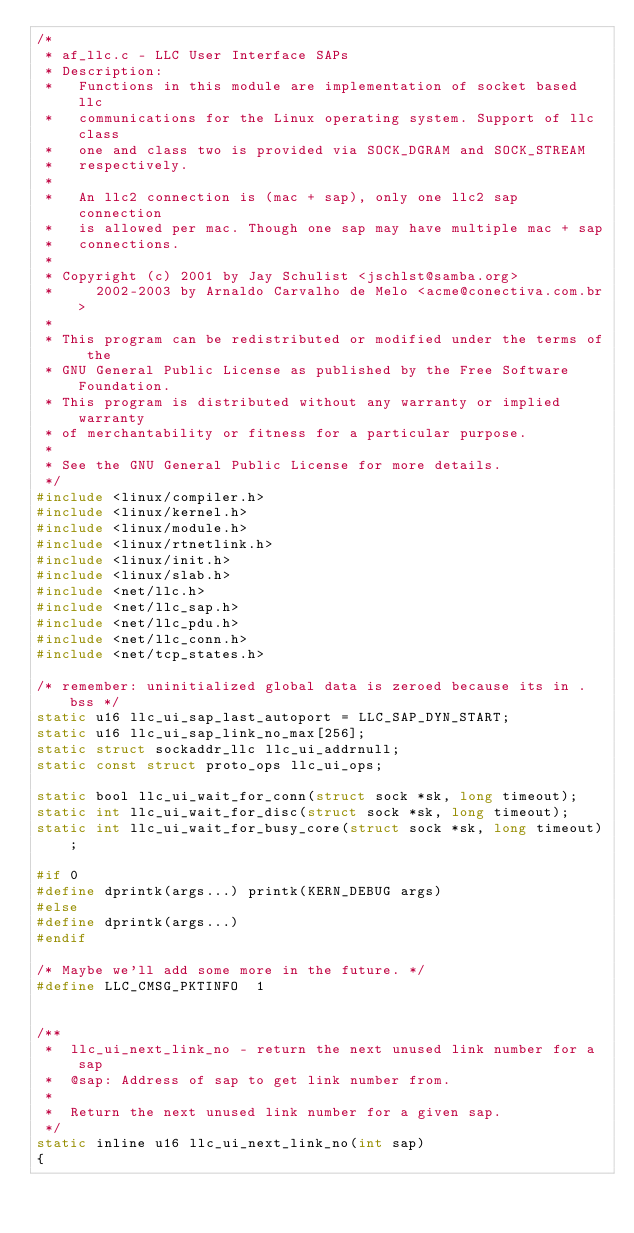<code> <loc_0><loc_0><loc_500><loc_500><_C_>/*
 * af_llc.c - LLC User Interface SAPs
 * Description:
 *   Functions in this module are implementation of socket based llc
 *   communications for the Linux operating system. Support of llc class
 *   one and class two is provided via SOCK_DGRAM and SOCK_STREAM
 *   respectively.
 *
 *   An llc2 connection is (mac + sap), only one llc2 sap connection
 *   is allowed per mac. Though one sap may have multiple mac + sap
 *   connections.
 *
 * Copyright (c) 2001 by Jay Schulist <jschlst@samba.org>
 *		 2002-2003 by Arnaldo Carvalho de Melo <acme@conectiva.com.br>
 *
 * This program can be redistributed or modified under the terms of the
 * GNU General Public License as published by the Free Software Foundation.
 * This program is distributed without any warranty or implied warranty
 * of merchantability or fitness for a particular purpose.
 *
 * See the GNU General Public License for more details.
 */
#include <linux/compiler.h>
#include <linux/kernel.h>
#include <linux/module.h>
#include <linux/rtnetlink.h>
#include <linux/init.h>
#include <linux/slab.h>
#include <net/llc.h>
#include <net/llc_sap.h>
#include <net/llc_pdu.h>
#include <net/llc_conn.h>
#include <net/tcp_states.h>

/* remember: uninitialized global data is zeroed because its in .bss */
static u16 llc_ui_sap_last_autoport = LLC_SAP_DYN_START;
static u16 llc_ui_sap_link_no_max[256];
static struct sockaddr_llc llc_ui_addrnull;
static const struct proto_ops llc_ui_ops;

static bool llc_ui_wait_for_conn(struct sock *sk, long timeout);
static int llc_ui_wait_for_disc(struct sock *sk, long timeout);
static int llc_ui_wait_for_busy_core(struct sock *sk, long timeout);

#if 0
#define dprintk(args...) printk(KERN_DEBUG args)
#else
#define dprintk(args...)
#endif

/* Maybe we'll add some more in the future. */
#define LLC_CMSG_PKTINFO	1


/**
 *	llc_ui_next_link_no - return the next unused link number for a sap
 *	@sap: Address of sap to get link number from.
 *
 *	Return the next unused link number for a given sap.
 */
static inline u16 llc_ui_next_link_no(int sap)
{</code> 